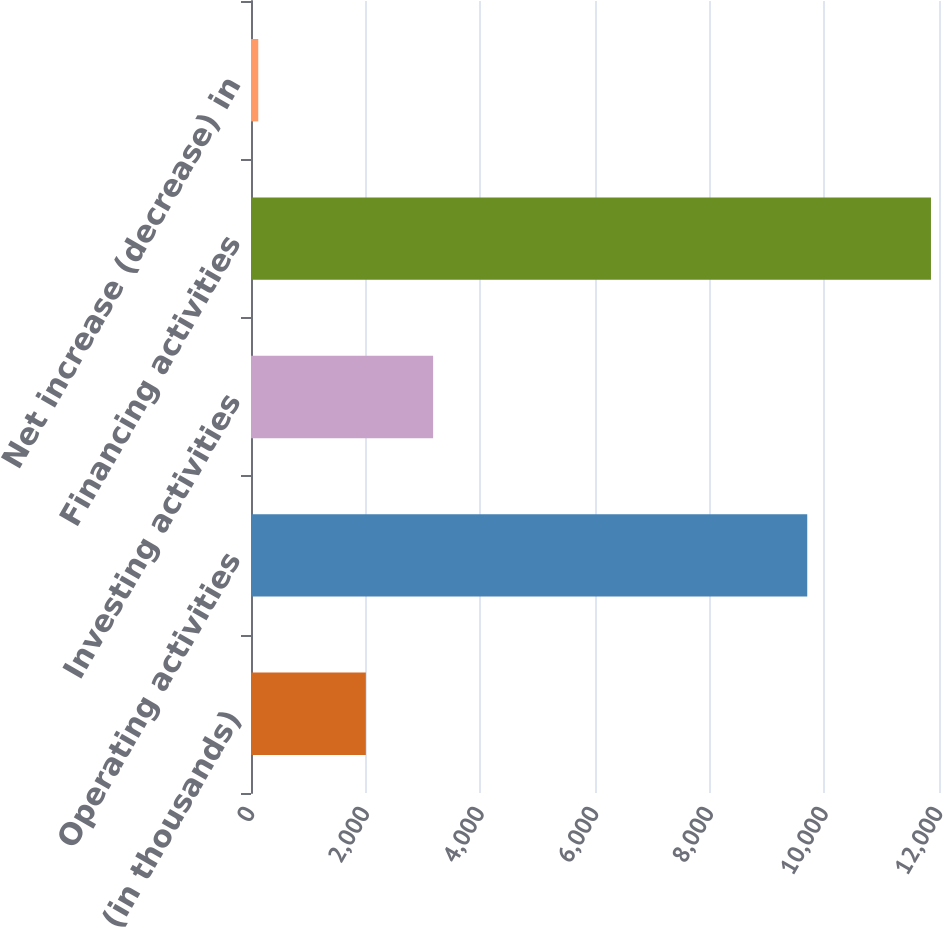<chart> <loc_0><loc_0><loc_500><loc_500><bar_chart><fcel>(in thousands)<fcel>Operating activities<fcel>Investing activities<fcel>Financing activities<fcel>Net increase (decrease) in<nl><fcel>2003<fcel>9702<fcel>3176.3<fcel>11860<fcel>127<nl></chart> 